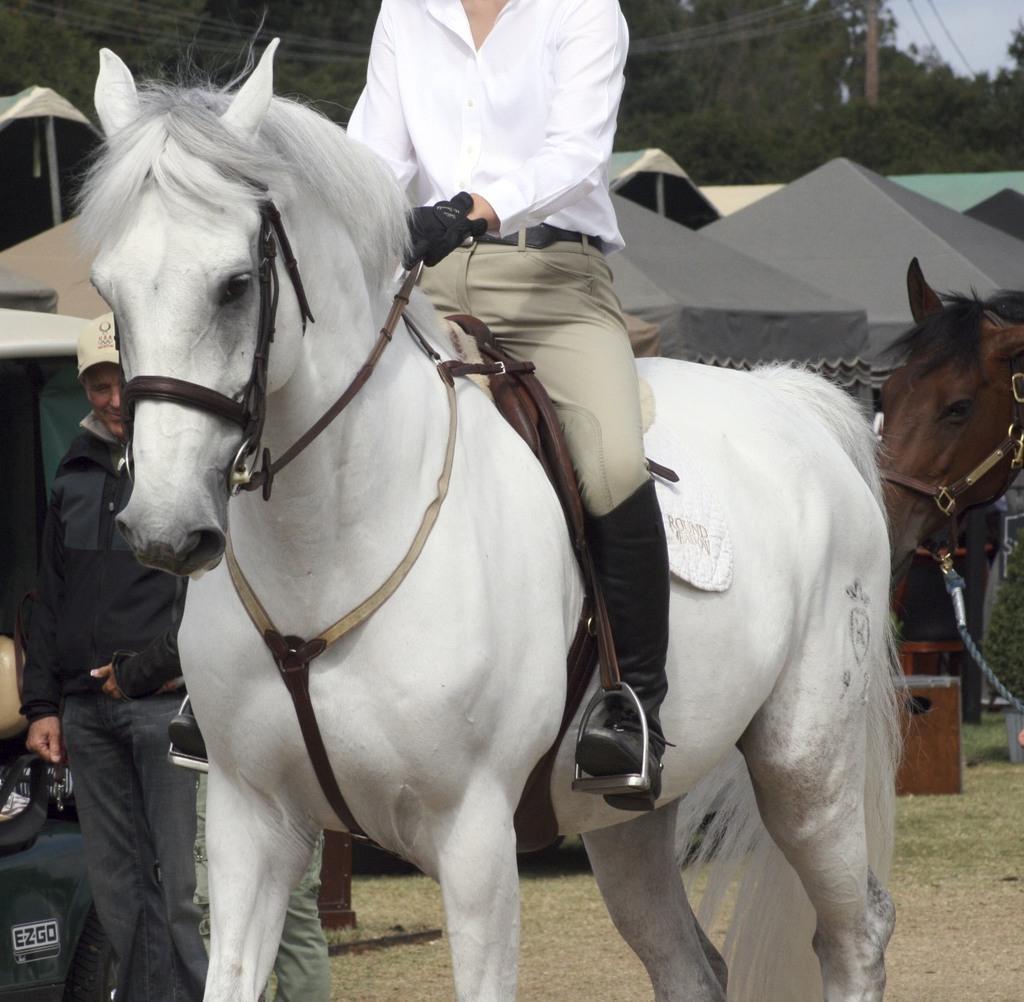How would you summarize this image in a sentence or two? We can see the man is sitting on a horse. He is holding a horse. On the left side we have a another person. he is standing. His wearing cap. We can in the background there is a tree,tent,pole,wire and sky. 